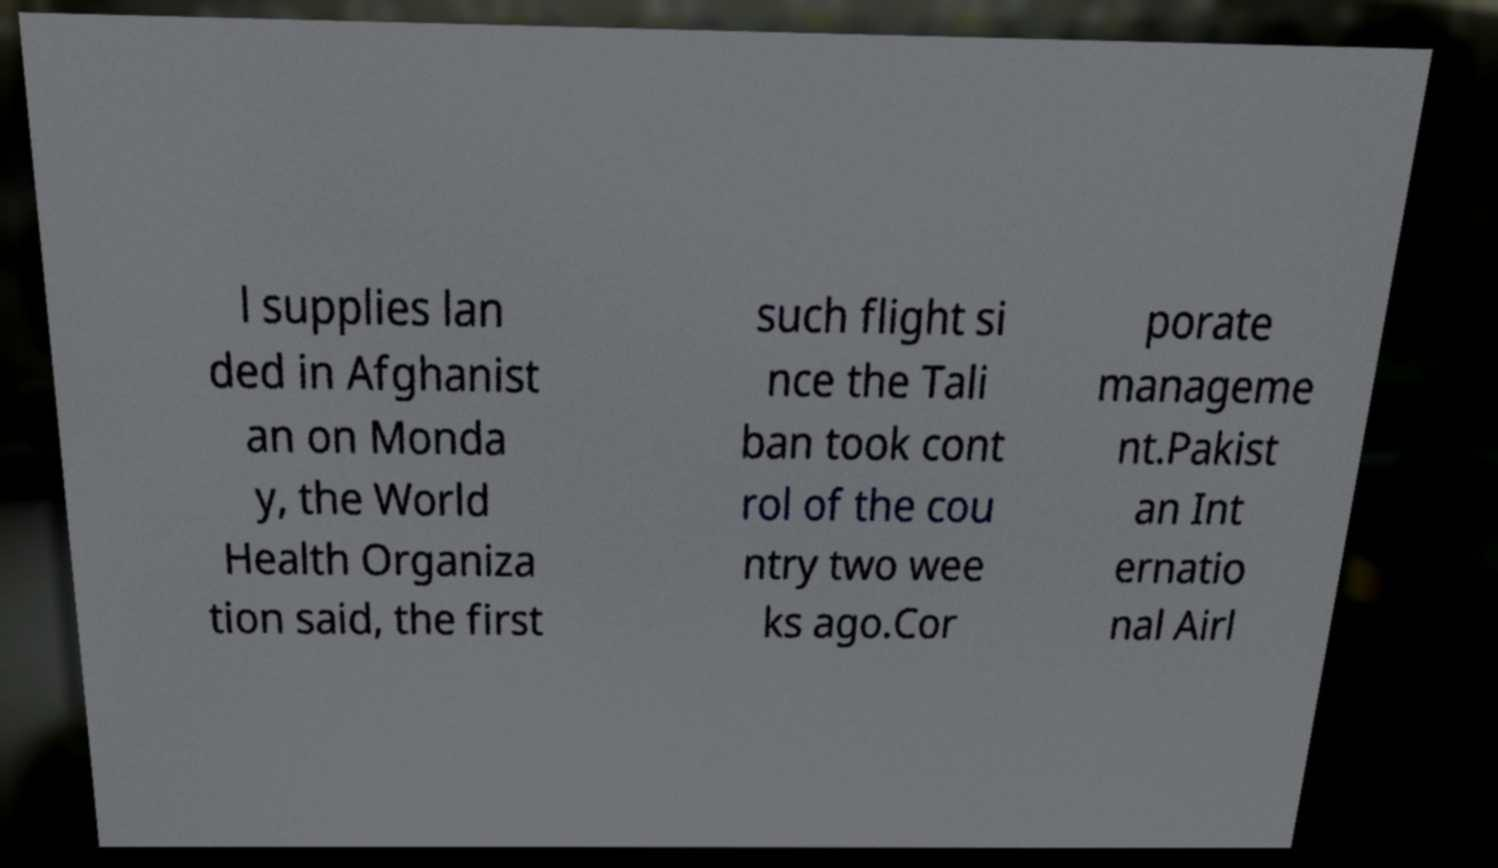For documentation purposes, I need the text within this image transcribed. Could you provide that? l supplies lan ded in Afghanist an on Monda y, the World Health Organiza tion said, the first such flight si nce the Tali ban took cont rol of the cou ntry two wee ks ago.Cor porate manageme nt.Pakist an Int ernatio nal Airl 